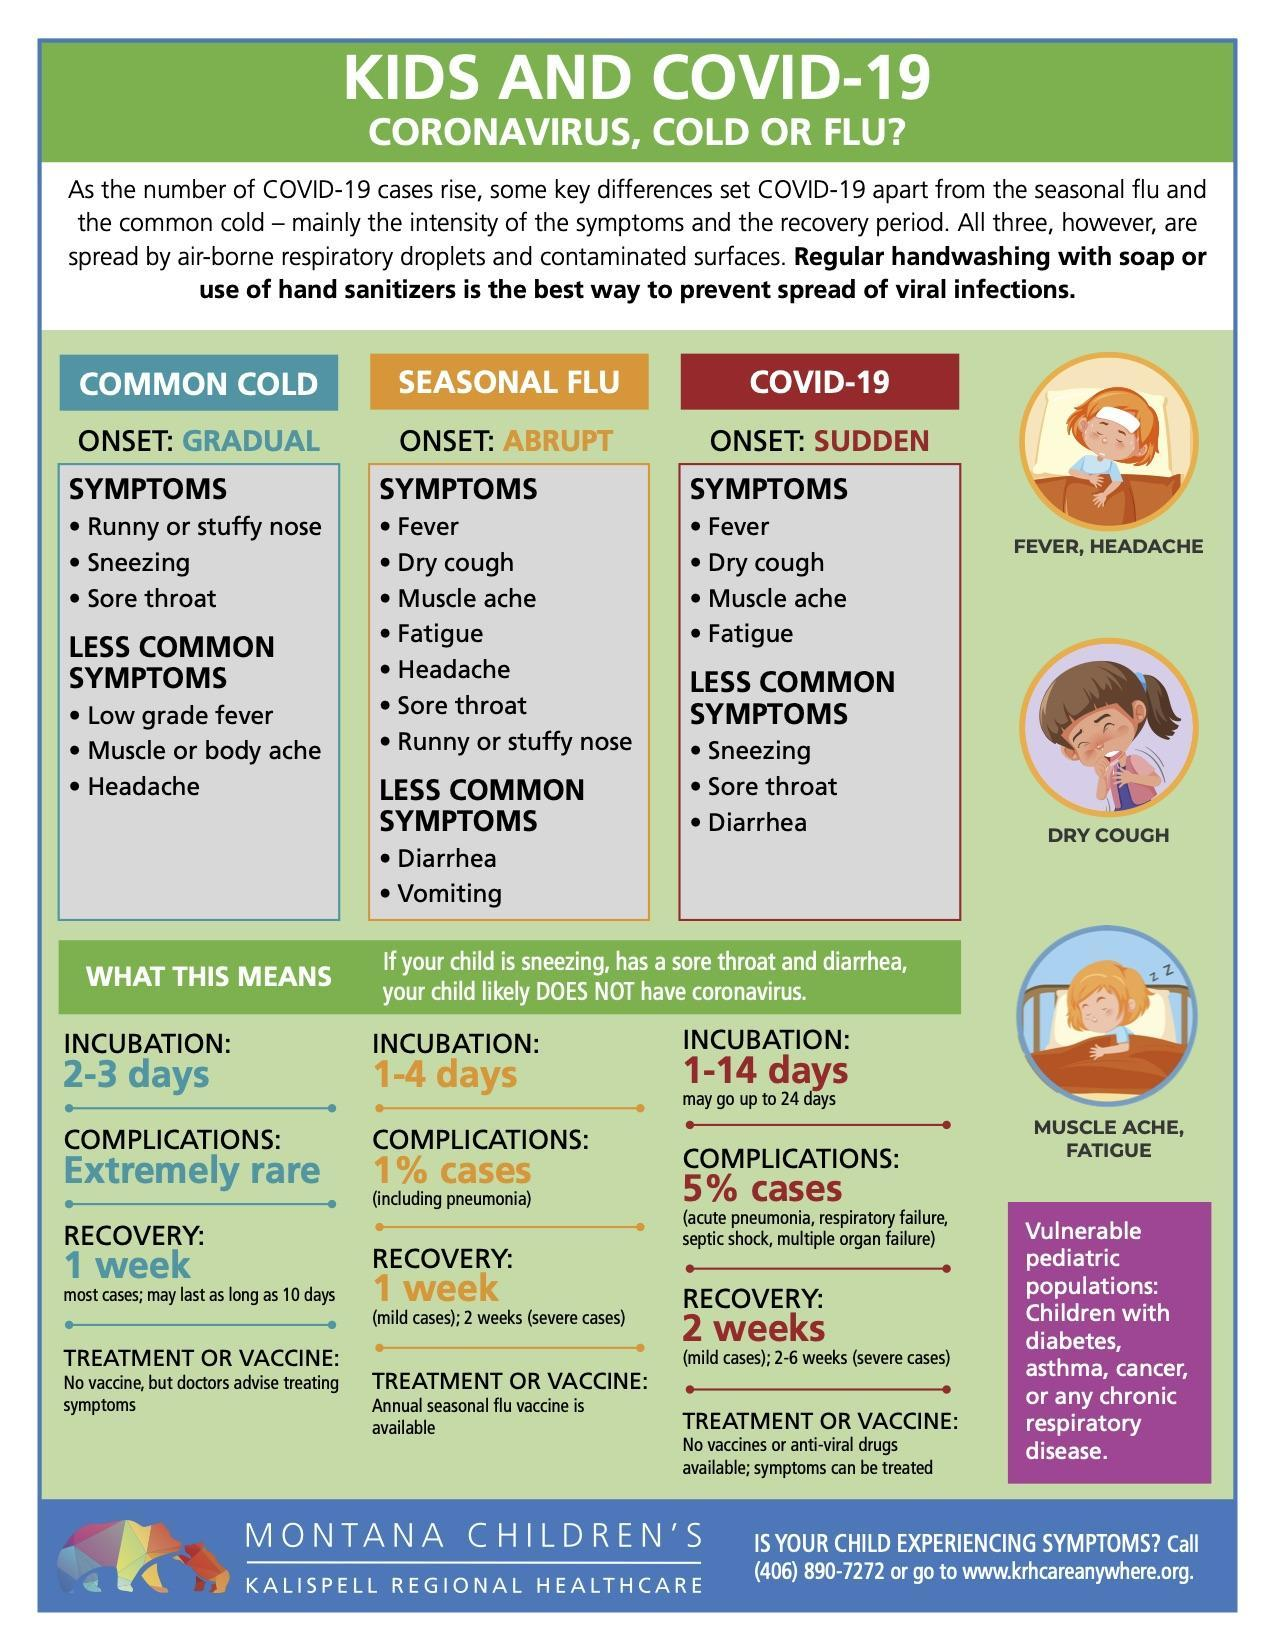Which illnesses have fatigue as common symptoms?
Answer the question with a short phrase. SEASONAL FLU, COVID-19 In which illness is complication expected to be below 1% of cases? COMMON COLD Which illnesses have diarrhea as their symptoms? SEASONAL FLU, COVID-19 How many children are shown in the infographic? 3 Which two illnesses have recovery of 1 week? COMMON COLD, SEASONAL FLU 